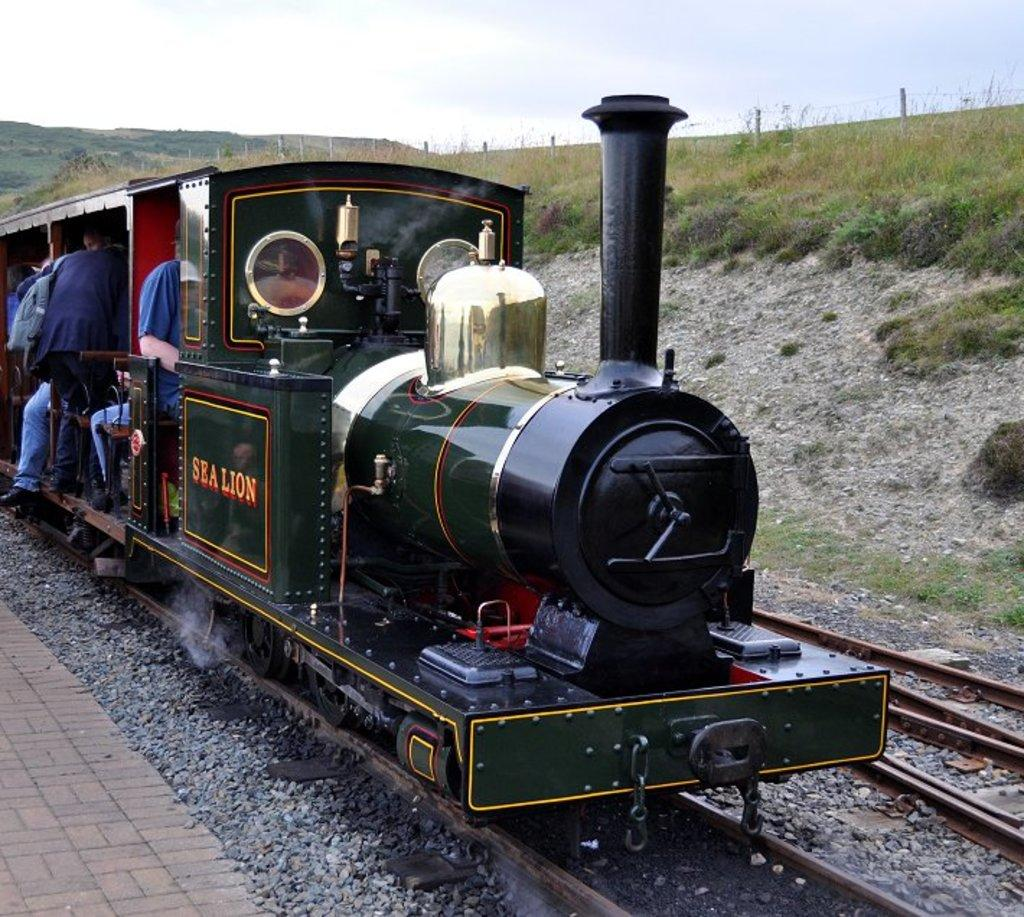What can be seen running along the ground in the image? There are two railway tracks in the image. What is on the railway tracks? There is a train on the tracks. Who or what is inside the train? There are people sitting in the train. What type of vegetation is on the right side of the image? There is green grass on the right side of the image. What is visible at the top of the image? The sky is visible at the top of the image. Can you see any baseball players or crows in the image? No, there are no baseball players or crows present in the image. Are there any flowers visible in the image? No, there are no flowers mentioned in the provided facts about the image. 